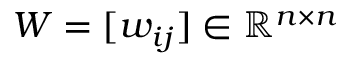<formula> <loc_0><loc_0><loc_500><loc_500>W = [ w _ { i j } ] \in \mathbb { R } ^ { n \times n }</formula> 